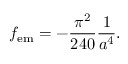<formula> <loc_0><loc_0><loc_500><loc_500>f _ { e m } = - { \frac { \pi ^ { 2 } } { 2 4 0 } } { \frac { 1 } { a ^ { 4 } } } .</formula> 